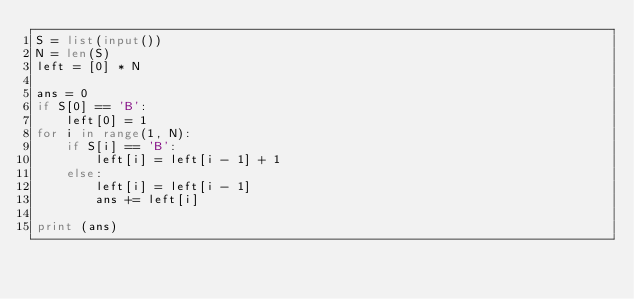<code> <loc_0><loc_0><loc_500><loc_500><_Python_>S = list(input())
N = len(S)
left = [0] * N

ans = 0
if S[0] == 'B':
    left[0] = 1
for i in range(1, N):
    if S[i] == 'B':
        left[i] = left[i - 1] + 1
    else:
        left[i] = left[i - 1]
        ans += left[i]

print (ans)</code> 